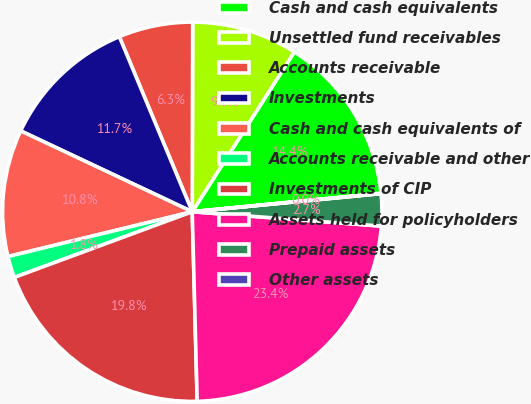Convert chart. <chart><loc_0><loc_0><loc_500><loc_500><pie_chart><fcel>Cash and cash equivalents<fcel>Unsettled fund receivables<fcel>Accounts receivable<fcel>Investments<fcel>Cash and cash equivalents of<fcel>Accounts receivable and other<fcel>Investments of CIP<fcel>Assets held for policyholders<fcel>Prepaid assets<fcel>Other assets<nl><fcel>14.4%<fcel>9.01%<fcel>6.32%<fcel>11.71%<fcel>10.81%<fcel>1.83%<fcel>19.79%<fcel>23.38%<fcel>2.73%<fcel>0.03%<nl></chart> 